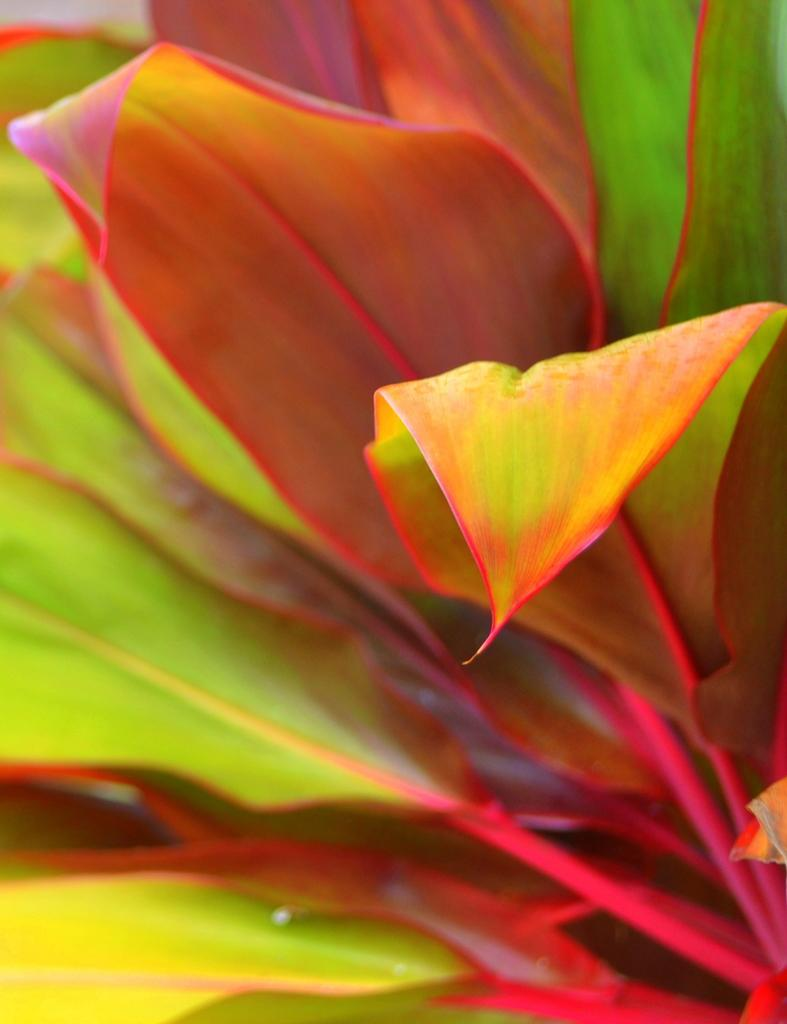What type of vegetation is present in the image? The image contains leaves. How would you describe the condition of the leaves? The leaves are full. What colors can be seen on the leaves in the image? The leaves have red colors and yellowish colors. What type of amusement can be seen in the image? There is no amusement present in the image; it features leaves with red and yellowish colors. How does the family interact with the leaves in the image? There is no family present in the image, and therefore no interaction with the leaves can be observed. 